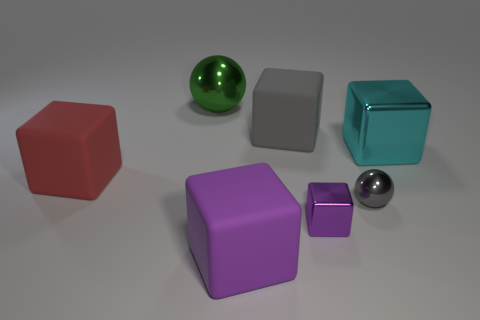Can you describe the different objects and their colors? Certainly! In the image, there are five distinct objects each with a unique color. From left to right, we have a red cube, a green shiny sphere, a gray cube, a turquoise cube, and a purple cube. Additionally, there's a small purple cube and a smaller gray shiny sphere in front of the larger purple and gray cubes respectively.  What can you infer about the lighting in the scene based on the shadows? The shadows in the image are soft and extend slightly to the right of the objects, indicating that there's a light source to the left, likely out of the frame. The diffuse nature of the shadows suggests that the light source is not extremely close to the objects, providing an even illumination over the scene. 